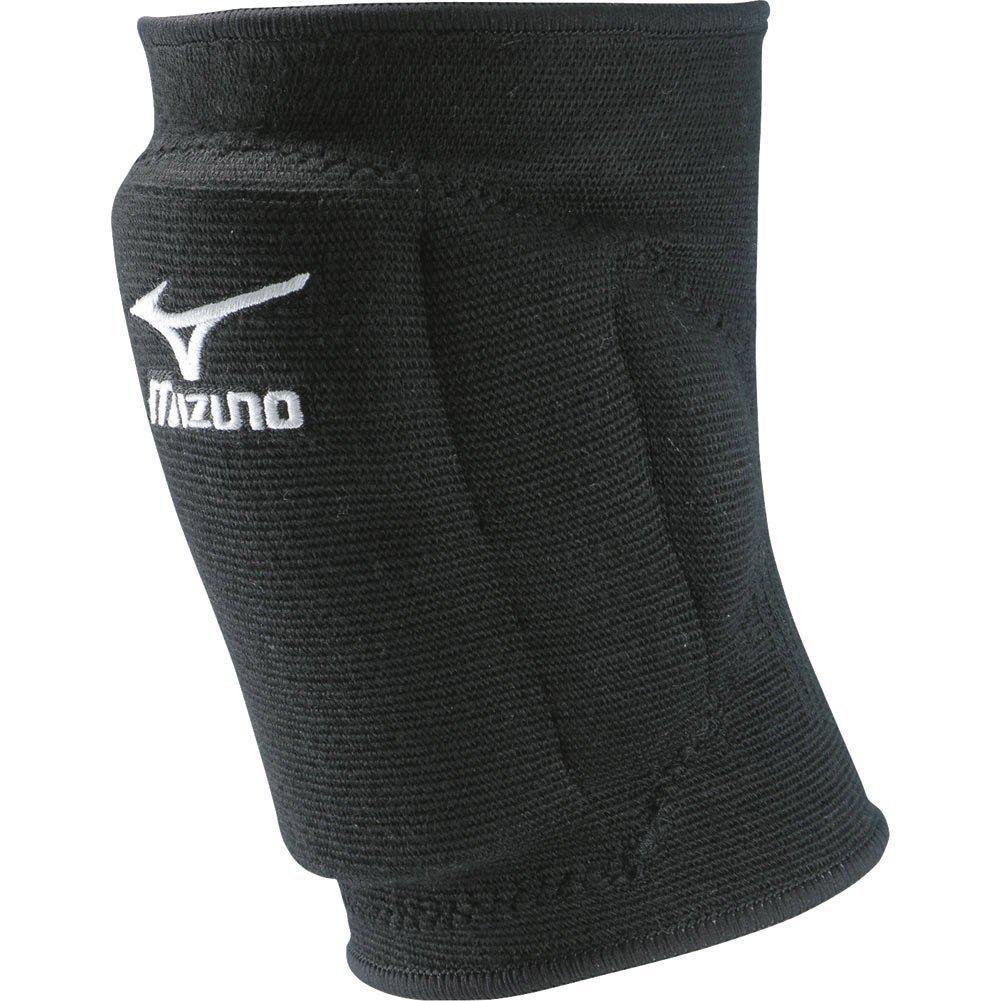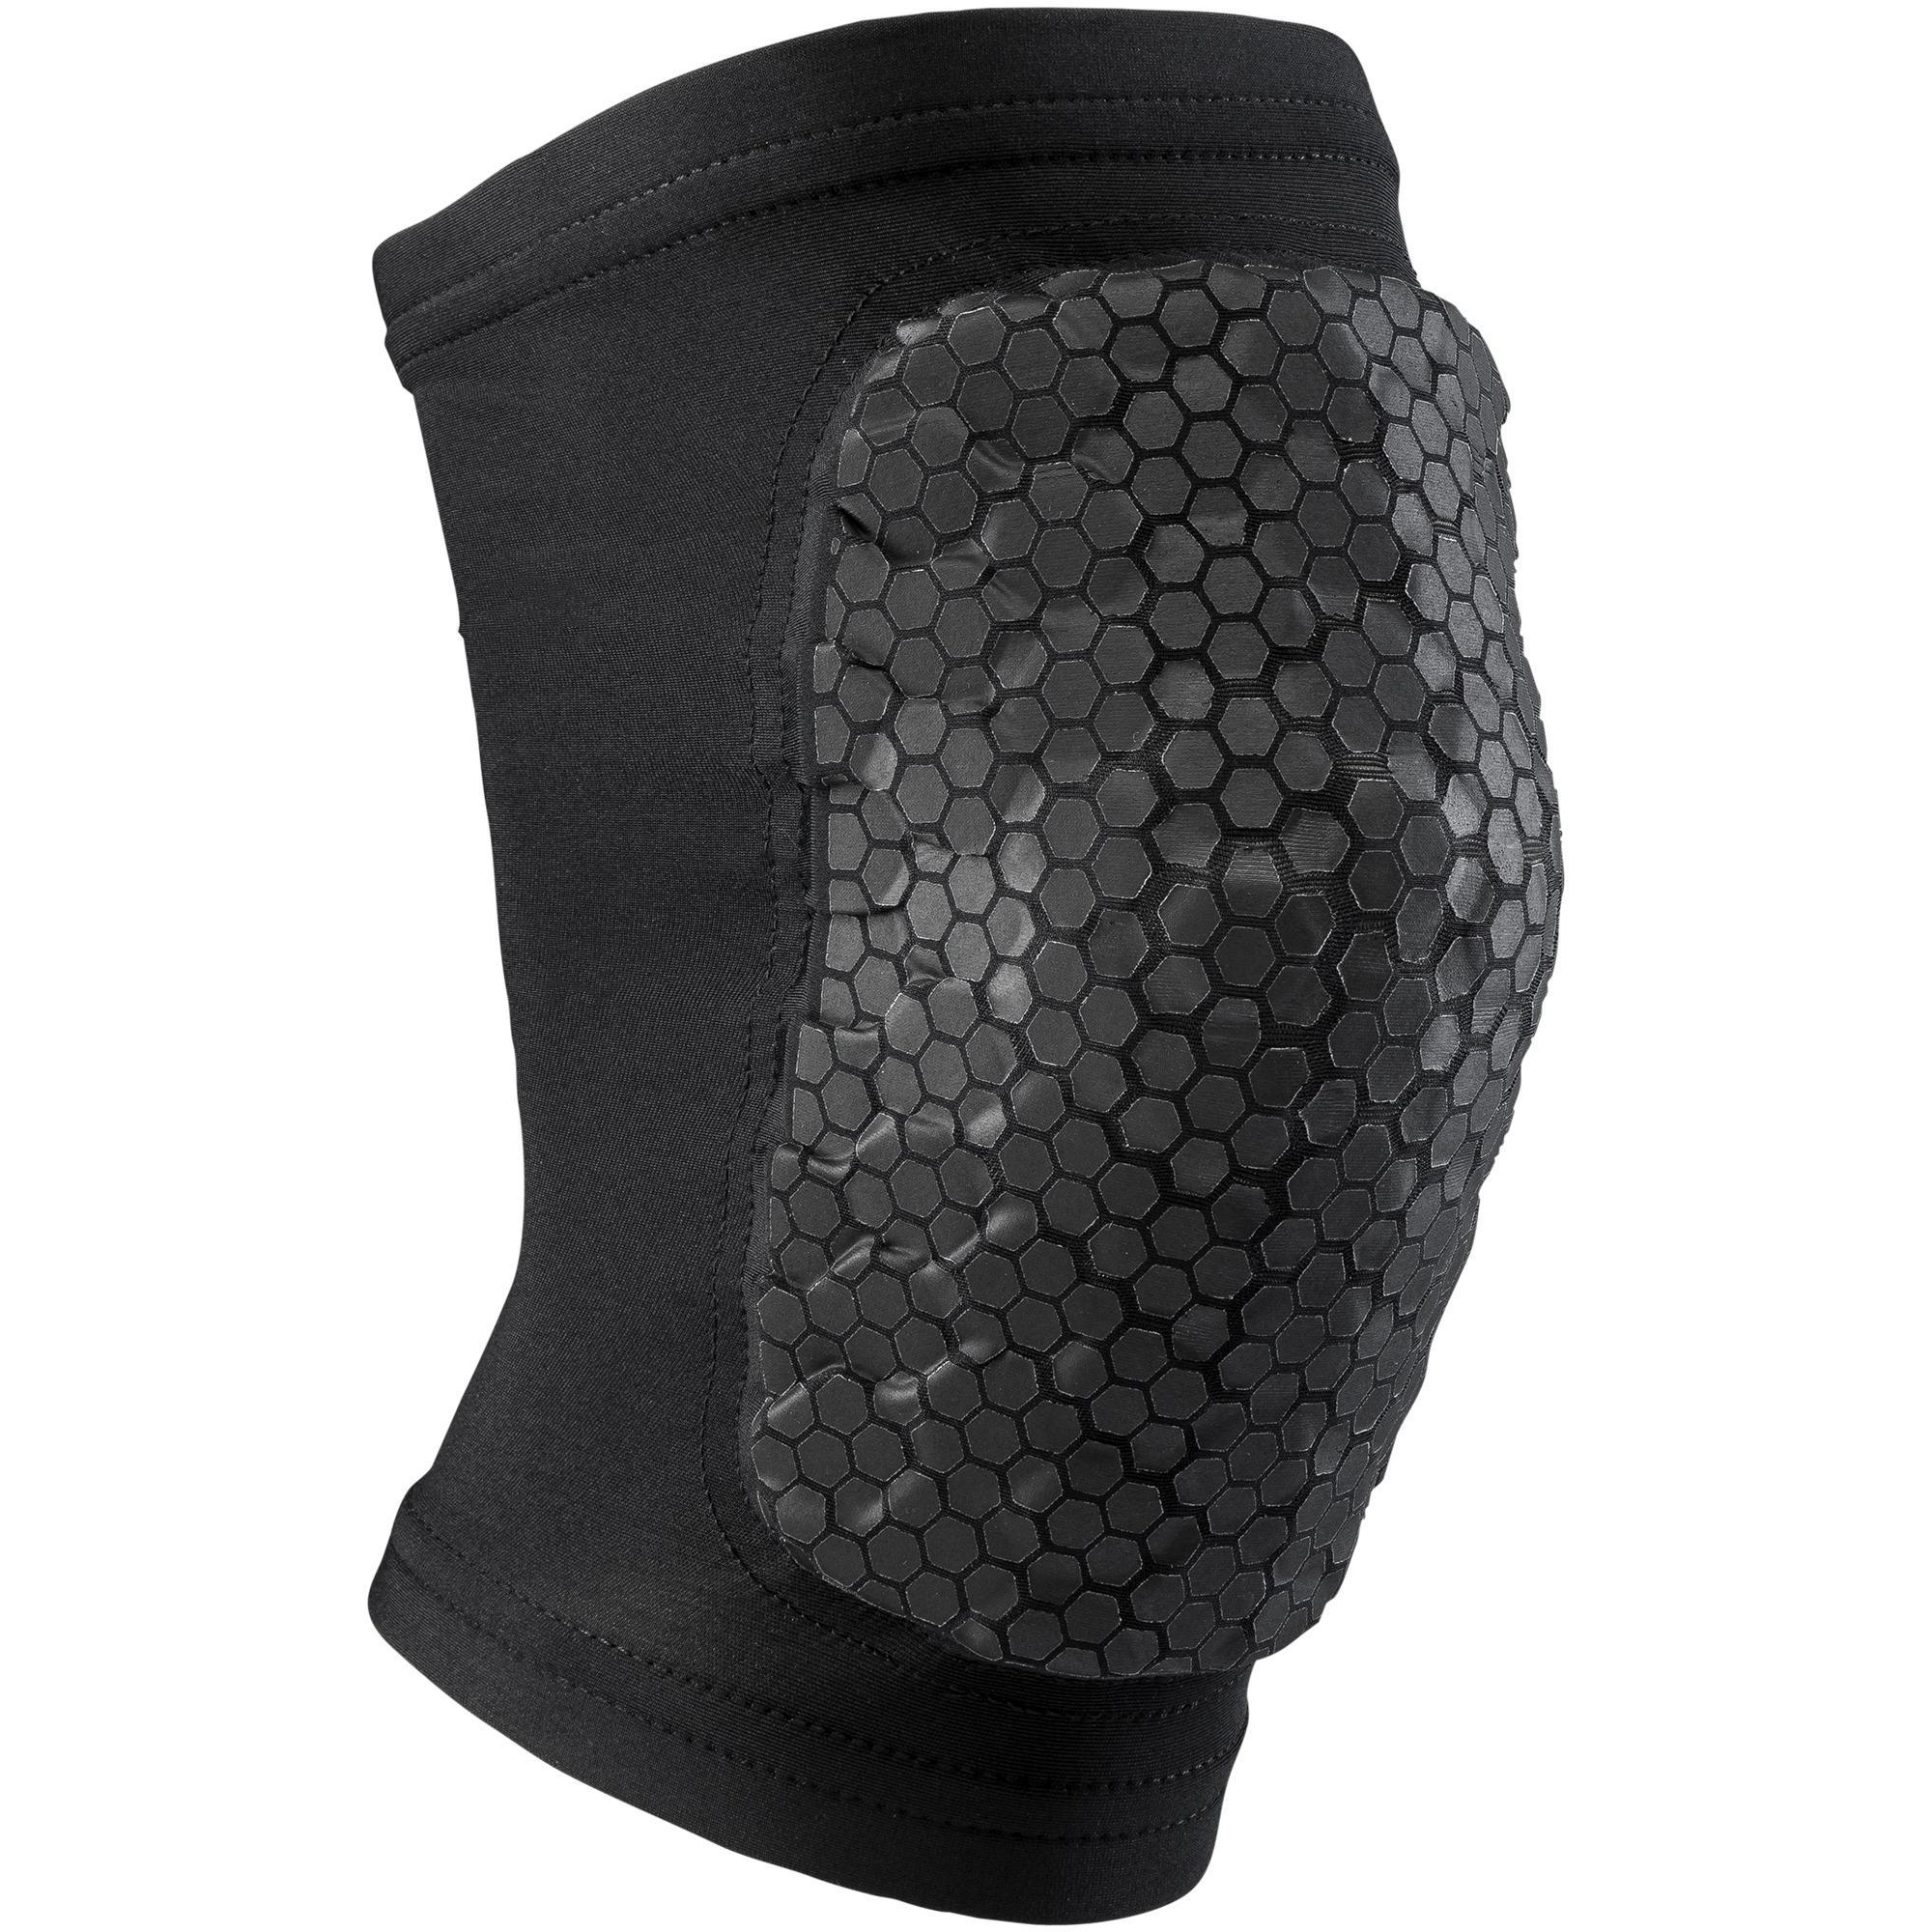The first image is the image on the left, the second image is the image on the right. Given the left and right images, does the statement "The knee pad is turned to the right in the image on the right." hold true? Answer yes or no. Yes. 